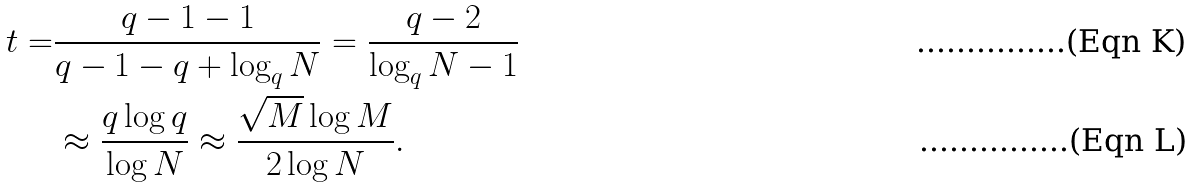Convert formula to latex. <formula><loc_0><loc_0><loc_500><loc_500>t = & \frac { q - 1 - 1 } { q - 1 - q + \log _ { q } { N } } = \frac { q - 2 } { \log _ { q } { N } - 1 } \\ & \approx \frac { q \log q } { \log N } \approx \frac { \sqrt { M } \log M } { 2 \log N } .</formula> 